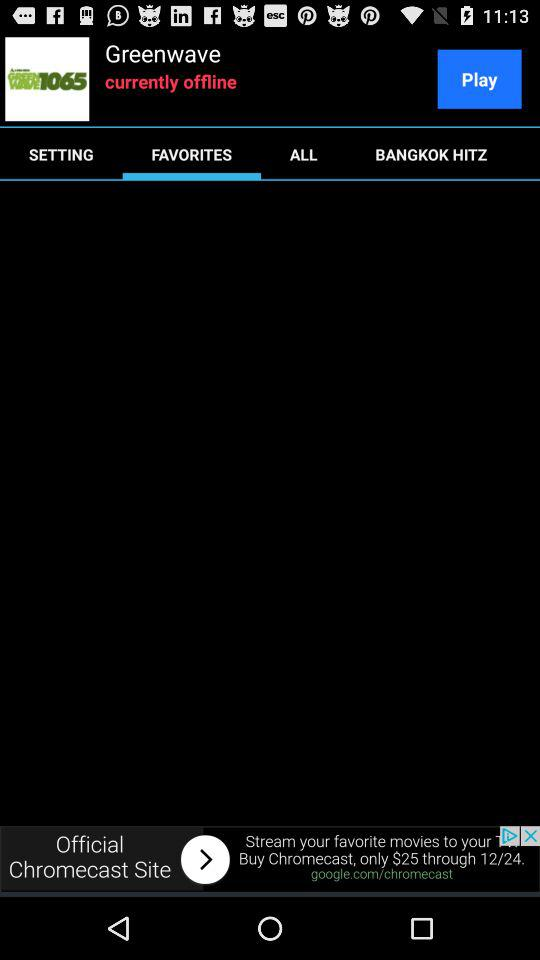Which tab is selected? The selected tab is "FAVORITES". 